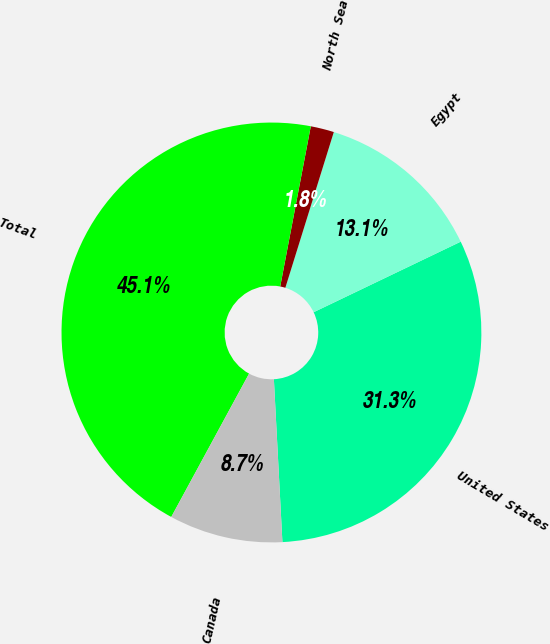Convert chart. <chart><loc_0><loc_0><loc_500><loc_500><pie_chart><fcel>United States<fcel>Egypt<fcel>North Sea<fcel>Total<fcel>Canada<nl><fcel>31.29%<fcel>13.08%<fcel>1.8%<fcel>45.09%<fcel>8.75%<nl></chart> 